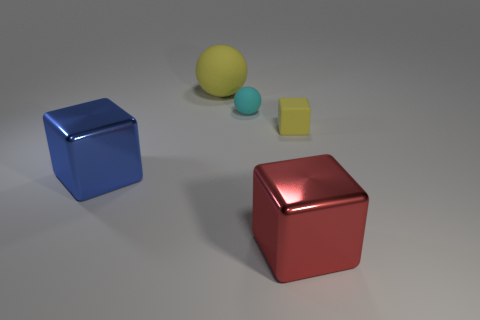Add 1 shiny blocks. How many objects exist? 6 Subtract all blocks. How many objects are left? 2 Add 1 blue cylinders. How many blue cylinders exist? 1 Subtract 0 green balls. How many objects are left? 5 Subtract all small purple rubber things. Subtract all cyan things. How many objects are left? 4 Add 3 yellow matte blocks. How many yellow matte blocks are left? 4 